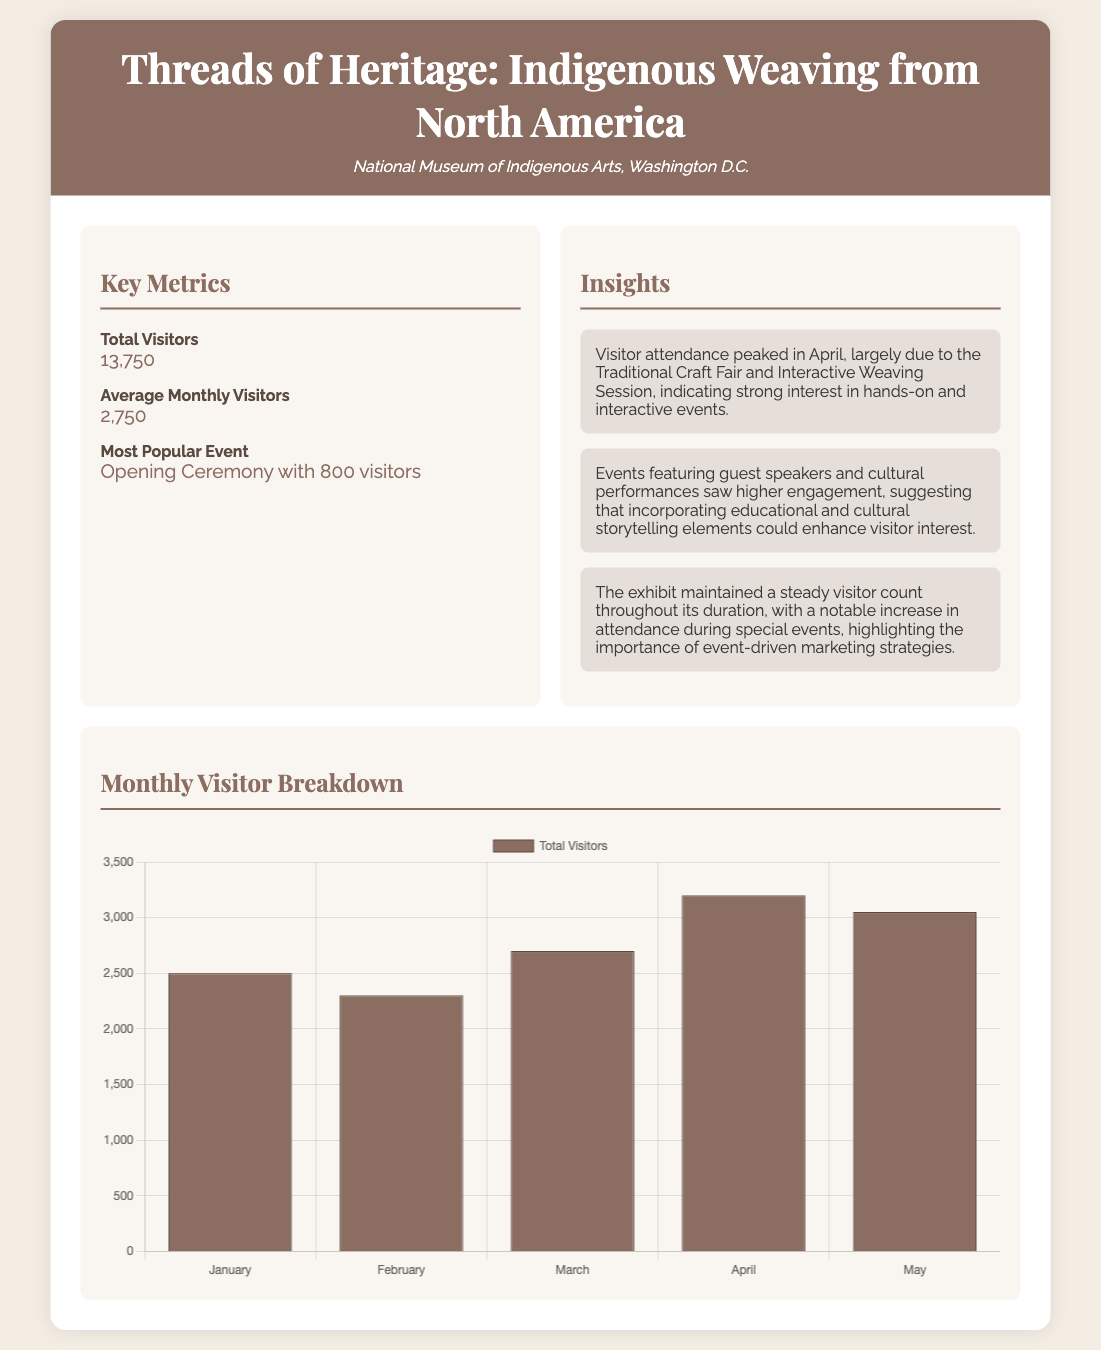What is the total number of visitors? The total number of visitors is explicitly provided in the document as 13,750 visitors.
Answer: 13,750 What is the average monthly number of visitors? The average monthly visitors is listed just below the total visitors in the document, which is 2,750.
Answer: 2,750 What was the most popular event? The document states that the most popular event was the Opening Ceremony with 800 visitors.
Answer: Opening Ceremony with 800 visitors In which month did visitor attendance peak? The document mentions that visitor attendance peaked in April due to specific events.
Answer: April How many visitors attended in March? The document shows the number of visitors in March as part of the monthly breakdown, which is 2,700.
Answer: 2,700 What does the insight about guest speakers suggest? The document provides insight indicating that events with guest speakers had higher engagement, suggesting the value of educational elements.
Answer: Higher engagement How many visitors attended in April? The document reveals that visitor attendance in April reached 3,200.
Answer: 3,200 What is the main theme of the exhibit? The exhibit's main theme is highlighted in the title, which is Indigenous Weaving from North America.
Answer: Indigenous Weaving from North America What color is used for the visitor chart? The background color of the bar representing total visitors in the chart is specified in the document as a shade of brown.
Answer: Brown 